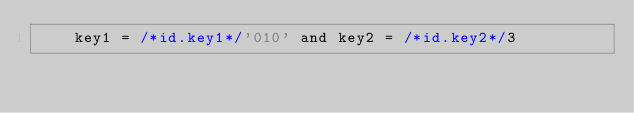Convert code to text. <code><loc_0><loc_0><loc_500><loc_500><_SQL_>		key1 = /*id.key1*/'010' and key2 = /*id.key2*/3
</code> 